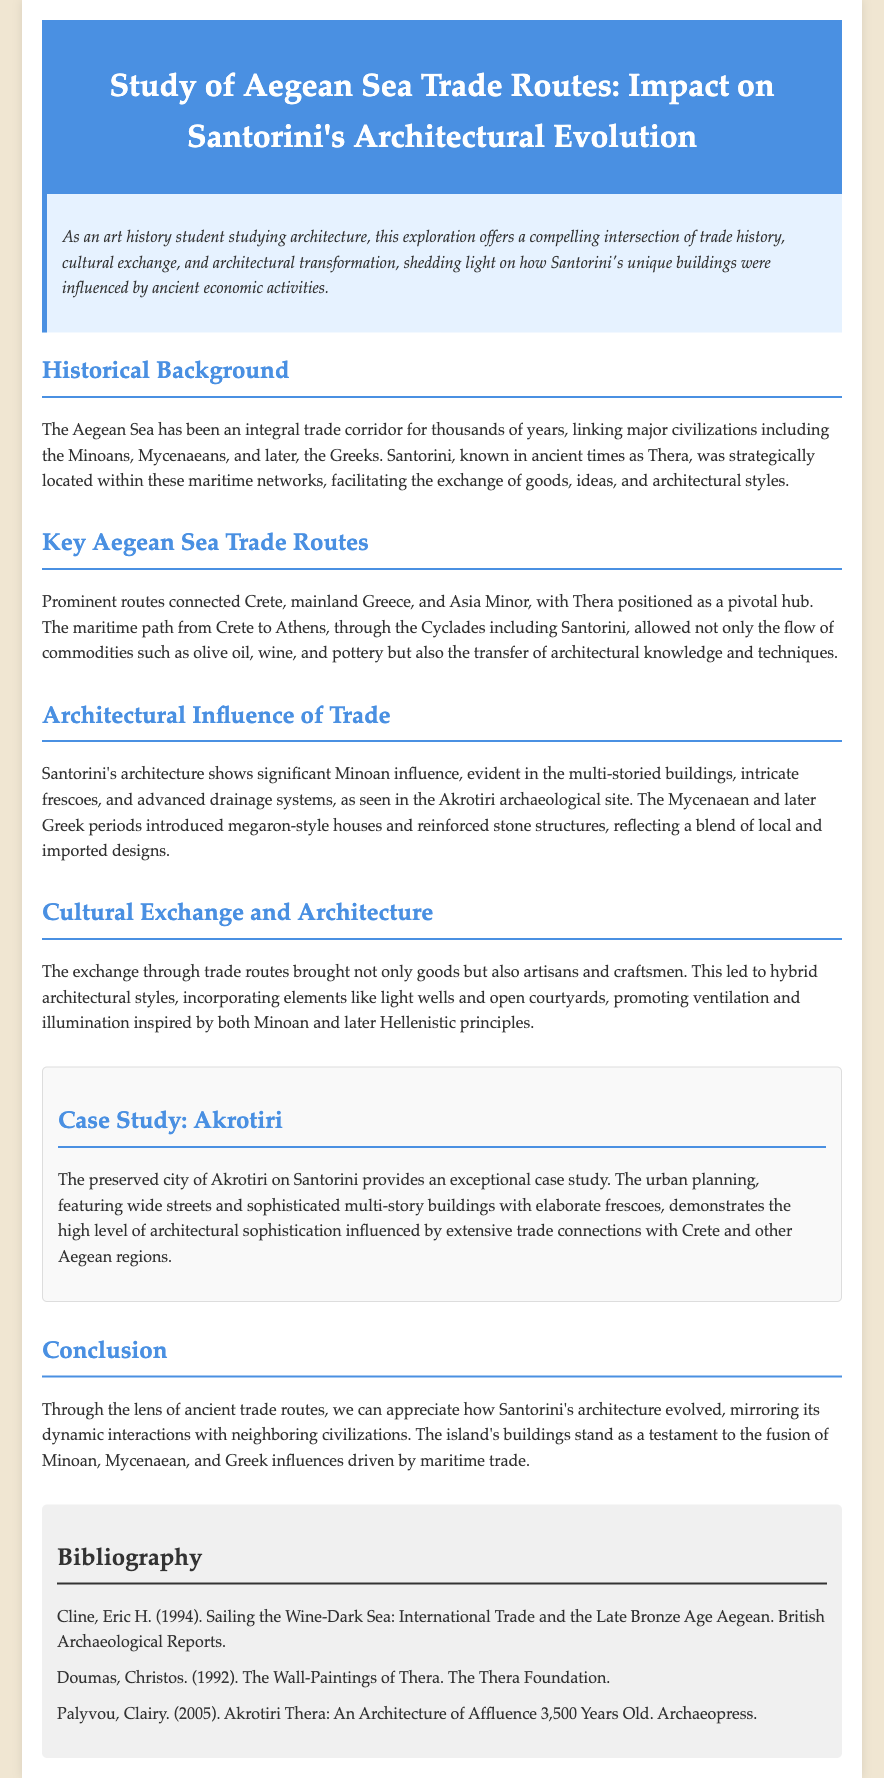What was Santorini known as in ancient times? The document states that Santorini was known as Thera in ancient times.
Answer: Thera What influenced Santorini's architectural styles? The document mentions that ancient trade routes facilitated the exchange of goods and architectural styles, impacting Santorini's architecture.
Answer: Trade routes What architectural feature demonstrates Minoan influence in Santorini? The multi-storied buildings, intricate frescoes, and advanced drainage systems are identified as significant Minoan influences in Santorini's architecture.
Answer: Multi-storied buildings Which archaeological site is highlighted as an example in the document? The case study section emphasizes Akrotiri as an exceptional case study for Santorini's architecture.
Answer: Akrotiri What material commodity was traded through Aegean Sea routes? The document lists olive oil, wine, and pottery as commodities exchanged along the trade routes.
Answer: Olive oil, wine, pottery What type of urban planning is evident in Akrotiri? The document describes the urban planning of Akrotiri, featuring wide streets and sophisticated buildings, indicating high architectural sophistication.
Answer: Wide streets Which civilizations were linked through Aegean Sea trade routes? The historical background section mentions the Minoans, Mycenaeans, and later Greeks as major civilizations linked through these routes.
Answer: Minoans, Mycenaeans, Greeks What does the conclusion of the document emphasize regarding Santorini's architecture? The conclusion emphasizes the architectural evolution of Santorini as a reflection of its dynamic interactions with neighboring civilizations.
Answer: Architectural evolution Which bibliography entry discusses the wall-paintings of Thera? The document references "The Wall-Paintings of Thera" by Christos Doumas in the bibliography.
Answer: Christos Doumas 